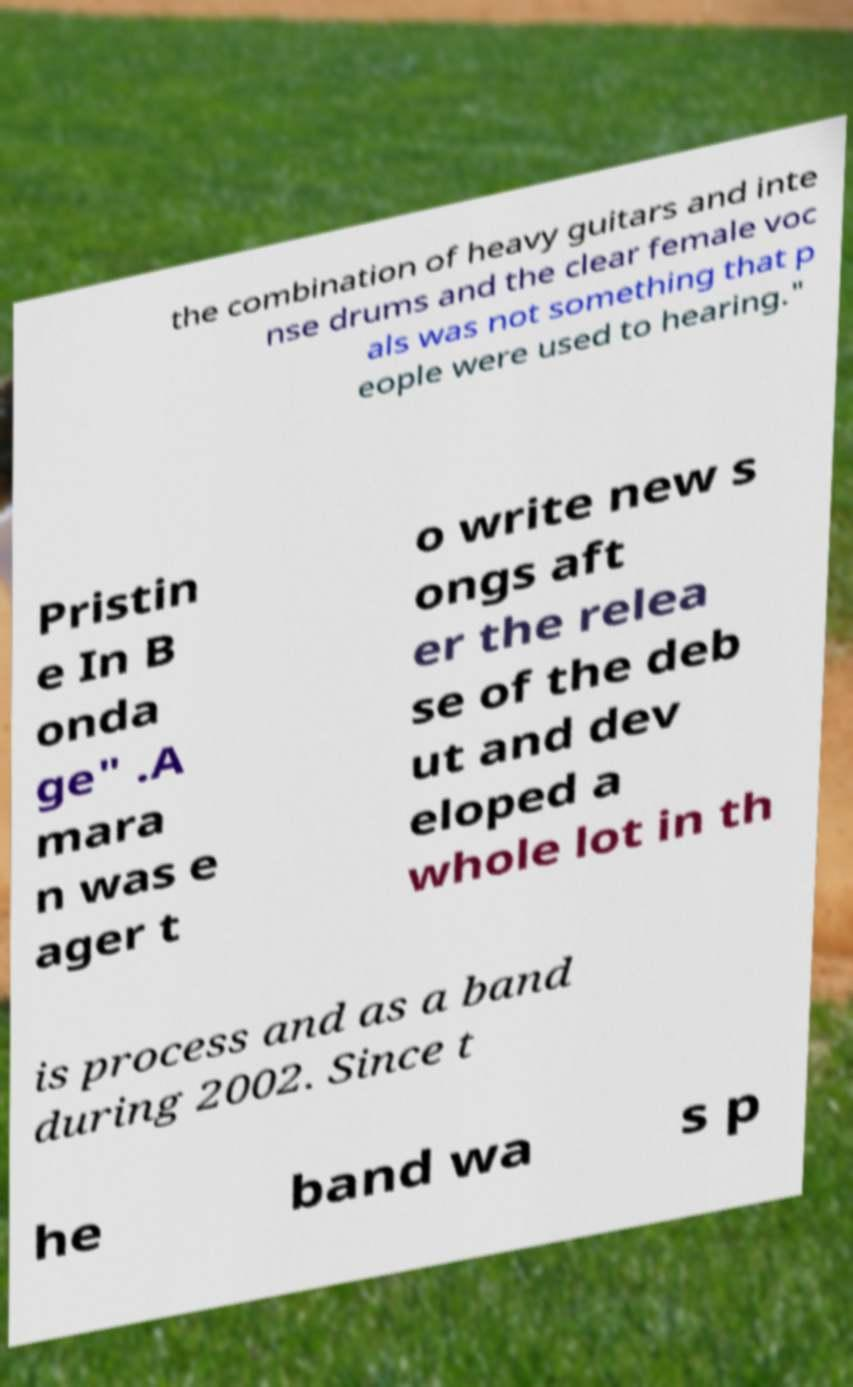Please read and relay the text visible in this image. What does it say? the combination of heavy guitars and inte nse drums and the clear female voc als was not something that p eople were used to hearing." Pristin e In B onda ge" .A mara n was e ager t o write new s ongs aft er the relea se of the deb ut and dev eloped a whole lot in th is process and as a band during 2002. Since t he band wa s p 